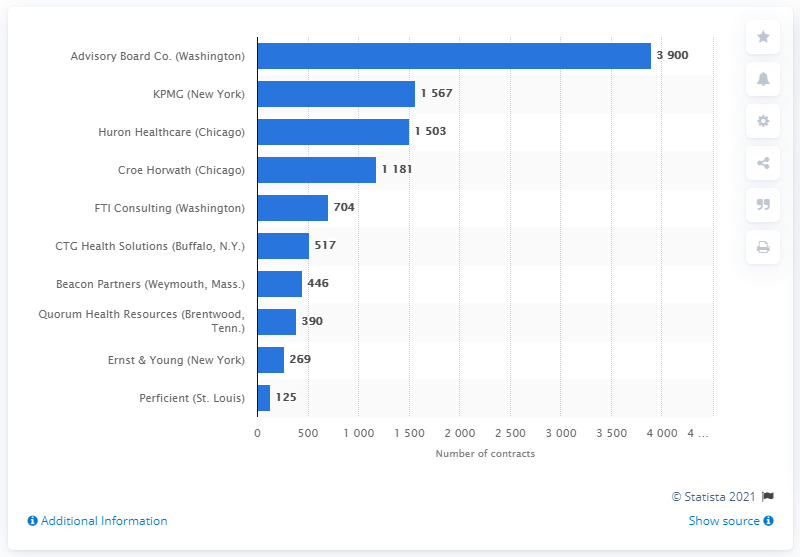Identify some key points in this picture. In 2013, Ernst & Young held 269 contracts. 